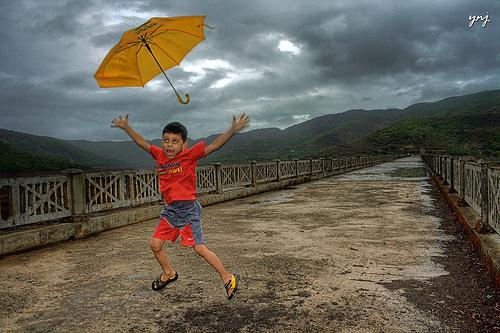Question: what time of day is it?
Choices:
A. Dawn.
B. Early evening.
C. Late night.
D. Midday.
Answer with the letter. Answer: B Question: what is in the air?
Choices:
A. A plane.
B. An umbrella.
C. A balloon.
D. A kite.
Answer with the letter. Answer: B Question: why is the boy in the air?
Choices:
A. He fell.
B. He jumped.
C. He's flying.
D. He's holding balloons.
Answer with the letter. Answer: B Question: what does the sky look like?
Choices:
A. Stormy.
B. Cloudy.
C. Blue.
D. Dark.
Answer with the letter. Answer: A Question: who is on the bridge?
Choices:
A. A young girl.
B. A boy.
C. A married couple.
D. A group of protestors.
Answer with the letter. Answer: B Question: where is the boy jumping on?
Choices:
A. A couch.
B. A bridge.
C. A bed.
D. A trampoline.
Answer with the letter. Answer: B 